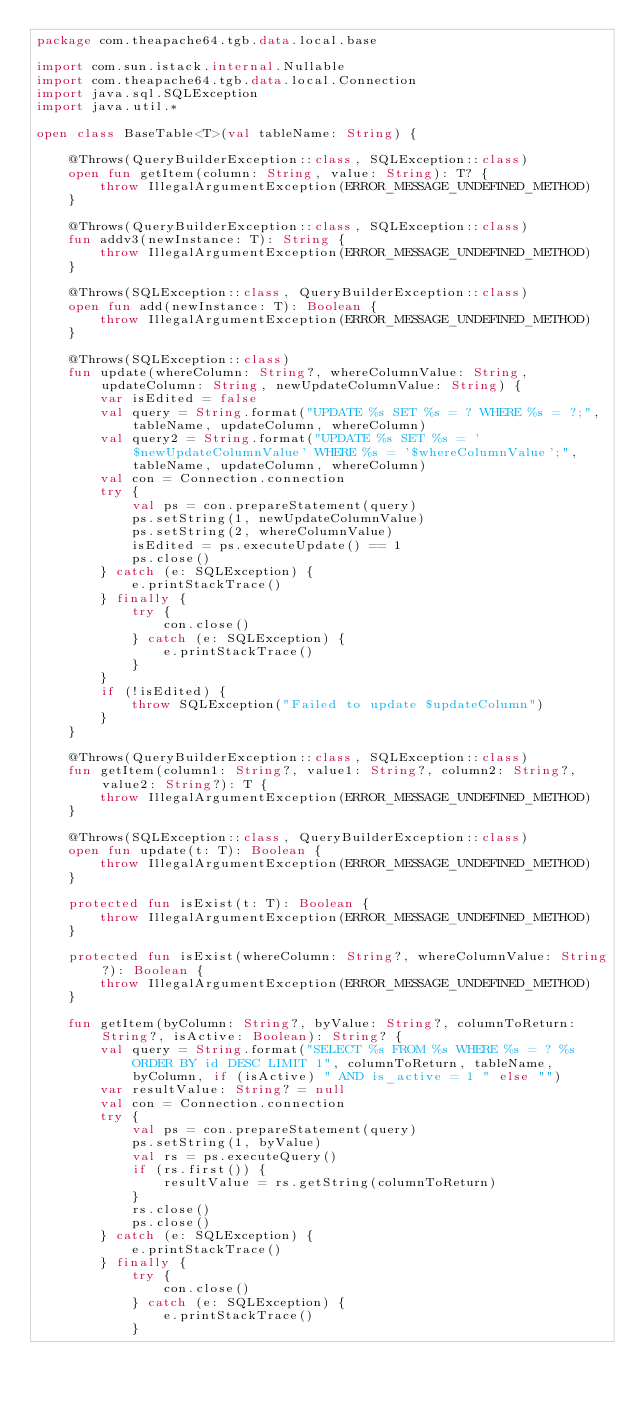Convert code to text. <code><loc_0><loc_0><loc_500><loc_500><_Kotlin_>package com.theapache64.tgb.data.local.base

import com.sun.istack.internal.Nullable
import com.theapache64.tgb.data.local.Connection
import java.sql.SQLException
import java.util.*

open class BaseTable<T>(val tableName: String) {

    @Throws(QueryBuilderException::class, SQLException::class)
    open fun getItem(column: String, value: String): T? {
        throw IllegalArgumentException(ERROR_MESSAGE_UNDEFINED_METHOD)
    }

    @Throws(QueryBuilderException::class, SQLException::class)
    fun addv3(newInstance: T): String {
        throw IllegalArgumentException(ERROR_MESSAGE_UNDEFINED_METHOD)
    }

    @Throws(SQLException::class, QueryBuilderException::class)
    open fun add(newInstance: T): Boolean {
        throw IllegalArgumentException(ERROR_MESSAGE_UNDEFINED_METHOD)
    }

    @Throws(SQLException::class)
    fun update(whereColumn: String?, whereColumnValue: String, updateColumn: String, newUpdateColumnValue: String) {
        var isEdited = false
        val query = String.format("UPDATE %s SET %s = ? WHERE %s = ?;", tableName, updateColumn, whereColumn)
        val query2 = String.format("UPDATE %s SET %s = '$newUpdateColumnValue' WHERE %s = '$whereColumnValue';", tableName, updateColumn, whereColumn)
        val con = Connection.connection
        try {
            val ps = con.prepareStatement(query)
            ps.setString(1, newUpdateColumnValue)
            ps.setString(2, whereColumnValue)
            isEdited = ps.executeUpdate() == 1
            ps.close()
        } catch (e: SQLException) {
            e.printStackTrace()
        } finally {
            try {
                con.close()
            } catch (e: SQLException) {
                e.printStackTrace()
            }
        }
        if (!isEdited) {
            throw SQLException("Failed to update $updateColumn")
        }
    }

    @Throws(QueryBuilderException::class, SQLException::class)
    fun getItem(column1: String?, value1: String?, column2: String?, value2: String?): T {
        throw IllegalArgumentException(ERROR_MESSAGE_UNDEFINED_METHOD)
    }

    @Throws(SQLException::class, QueryBuilderException::class)
    open fun update(t: T): Boolean {
        throw IllegalArgumentException(ERROR_MESSAGE_UNDEFINED_METHOD)
    }

    protected fun isExist(t: T): Boolean {
        throw IllegalArgumentException(ERROR_MESSAGE_UNDEFINED_METHOD)
    }

    protected fun isExist(whereColumn: String?, whereColumnValue: String?): Boolean {
        throw IllegalArgumentException(ERROR_MESSAGE_UNDEFINED_METHOD)
    }

    fun getItem(byColumn: String?, byValue: String?, columnToReturn: String?, isActive: Boolean): String? {
        val query = String.format("SELECT %s FROM %s WHERE %s = ? %s ORDER BY id DESC LIMIT 1", columnToReturn, tableName, byColumn, if (isActive) " AND is_active = 1 " else "")
        var resultValue: String? = null
        val con = Connection.connection
        try {
            val ps = con.prepareStatement(query)
            ps.setString(1, byValue)
            val rs = ps.executeQuery()
            if (rs.first()) {
                resultValue = rs.getString(columnToReturn)
            }
            rs.close()
            ps.close()
        } catch (e: SQLException) {
            e.printStackTrace()
        } finally {
            try {
                con.close()
            } catch (e: SQLException) {
                e.printStackTrace()
            }</code> 